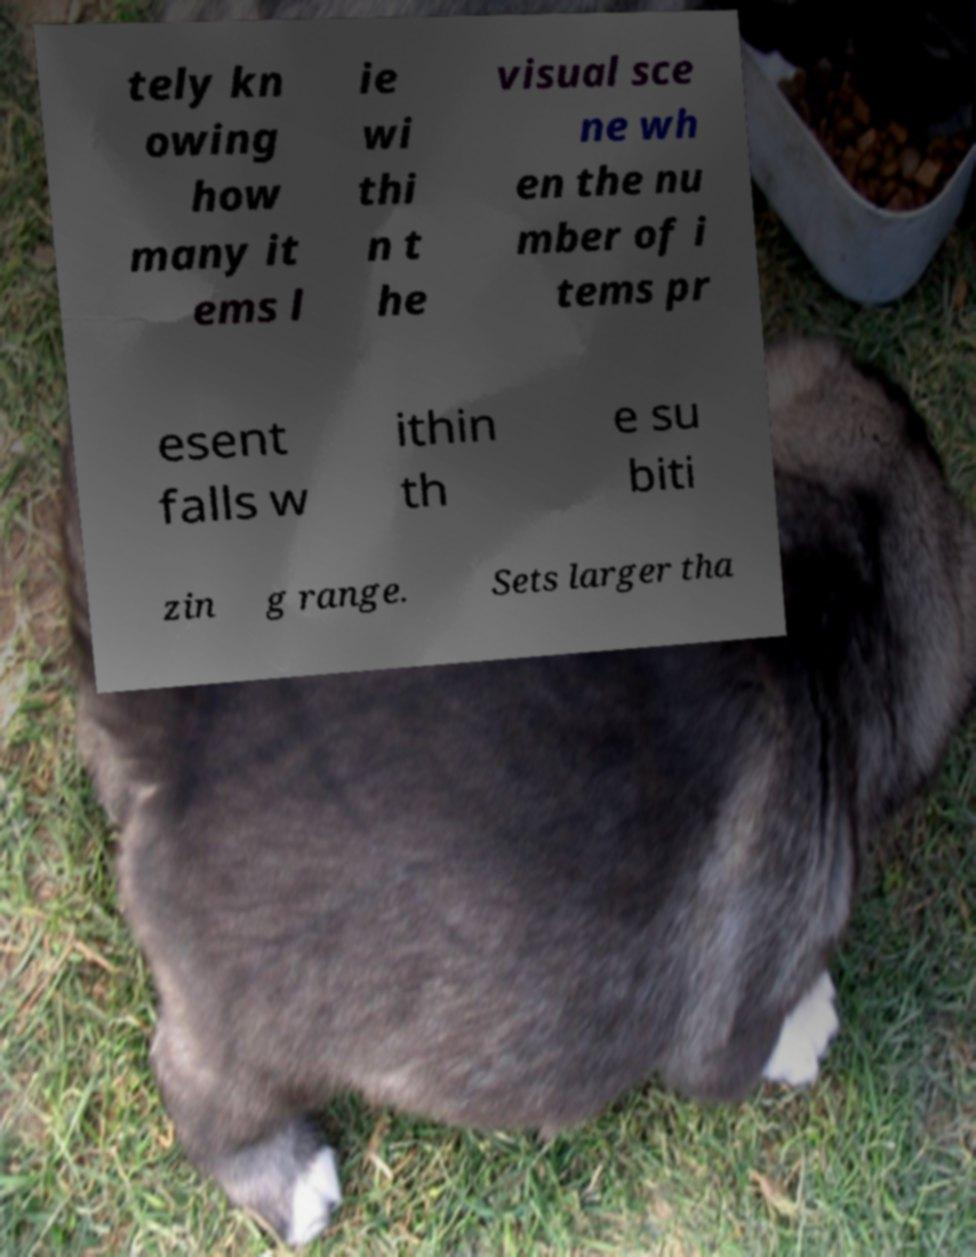For documentation purposes, I need the text within this image transcribed. Could you provide that? tely kn owing how many it ems l ie wi thi n t he visual sce ne wh en the nu mber of i tems pr esent falls w ithin th e su biti zin g range. Sets larger tha 